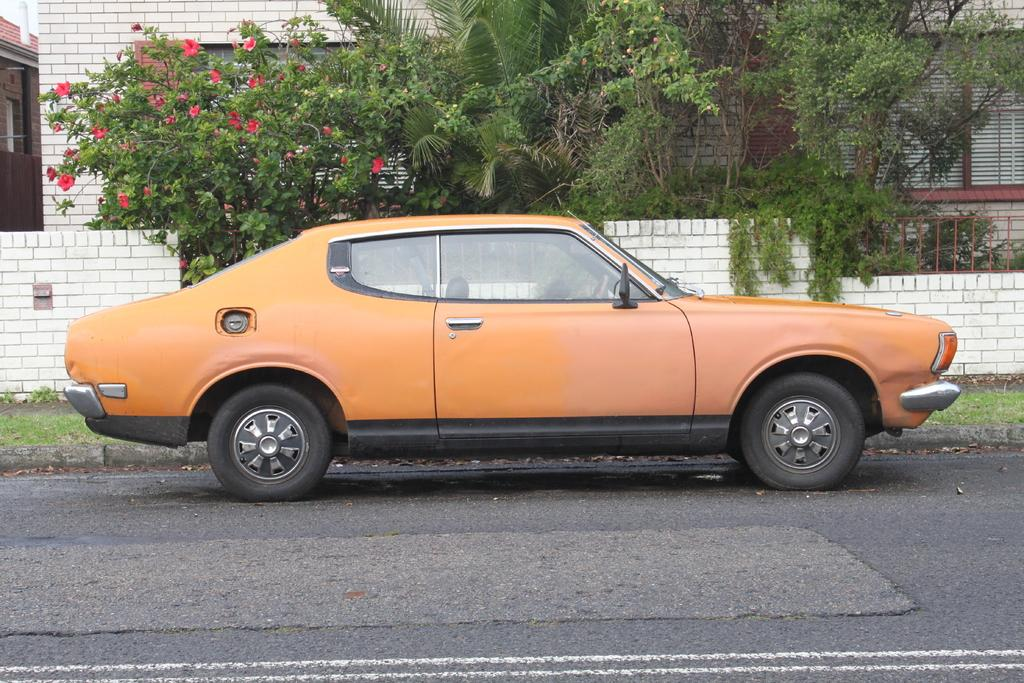What is the main subject of the image? There is a car on the road in the image. What can be seen in the background of the image? There are trees, plants, grass, a fence wall, and a building visible in the background of the image. What type of power is being generated by the car in the image? The image does not provide information about the car's power source, so it cannot be determined from the image. 